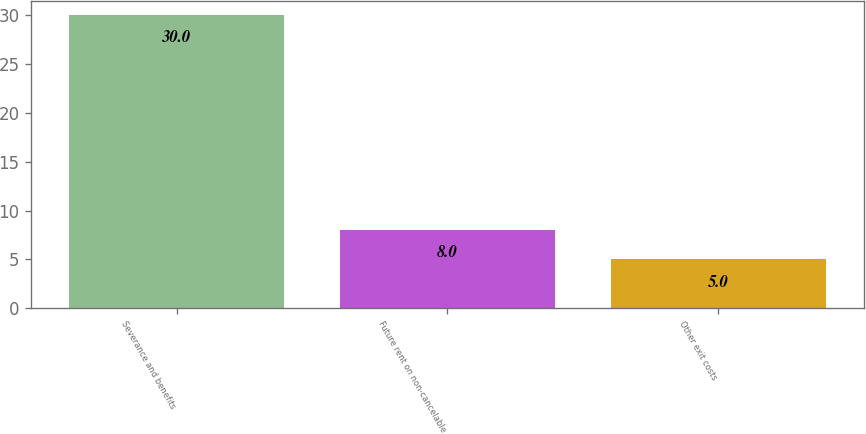Convert chart. <chart><loc_0><loc_0><loc_500><loc_500><bar_chart><fcel>Severance and benefits<fcel>Future rent on non-cancelable<fcel>Other exit costs<nl><fcel>30<fcel>8<fcel>5<nl></chart> 